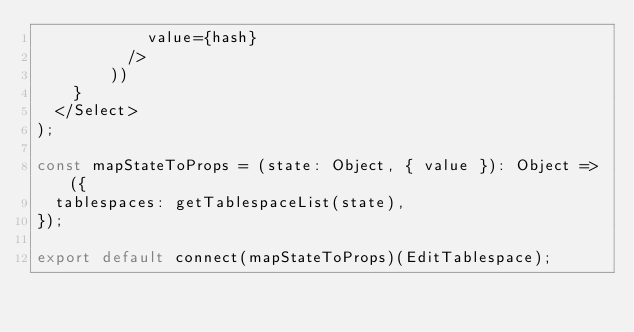Convert code to text. <code><loc_0><loc_0><loc_500><loc_500><_JavaScript_>            value={hash}
          />
        ))
    }
  </Select>
);

const mapStateToProps = (state: Object, { value }): Object => ({
  tablespaces: getTablespaceList(state),
});

export default connect(mapStateToProps)(EditTablespace);
</code> 